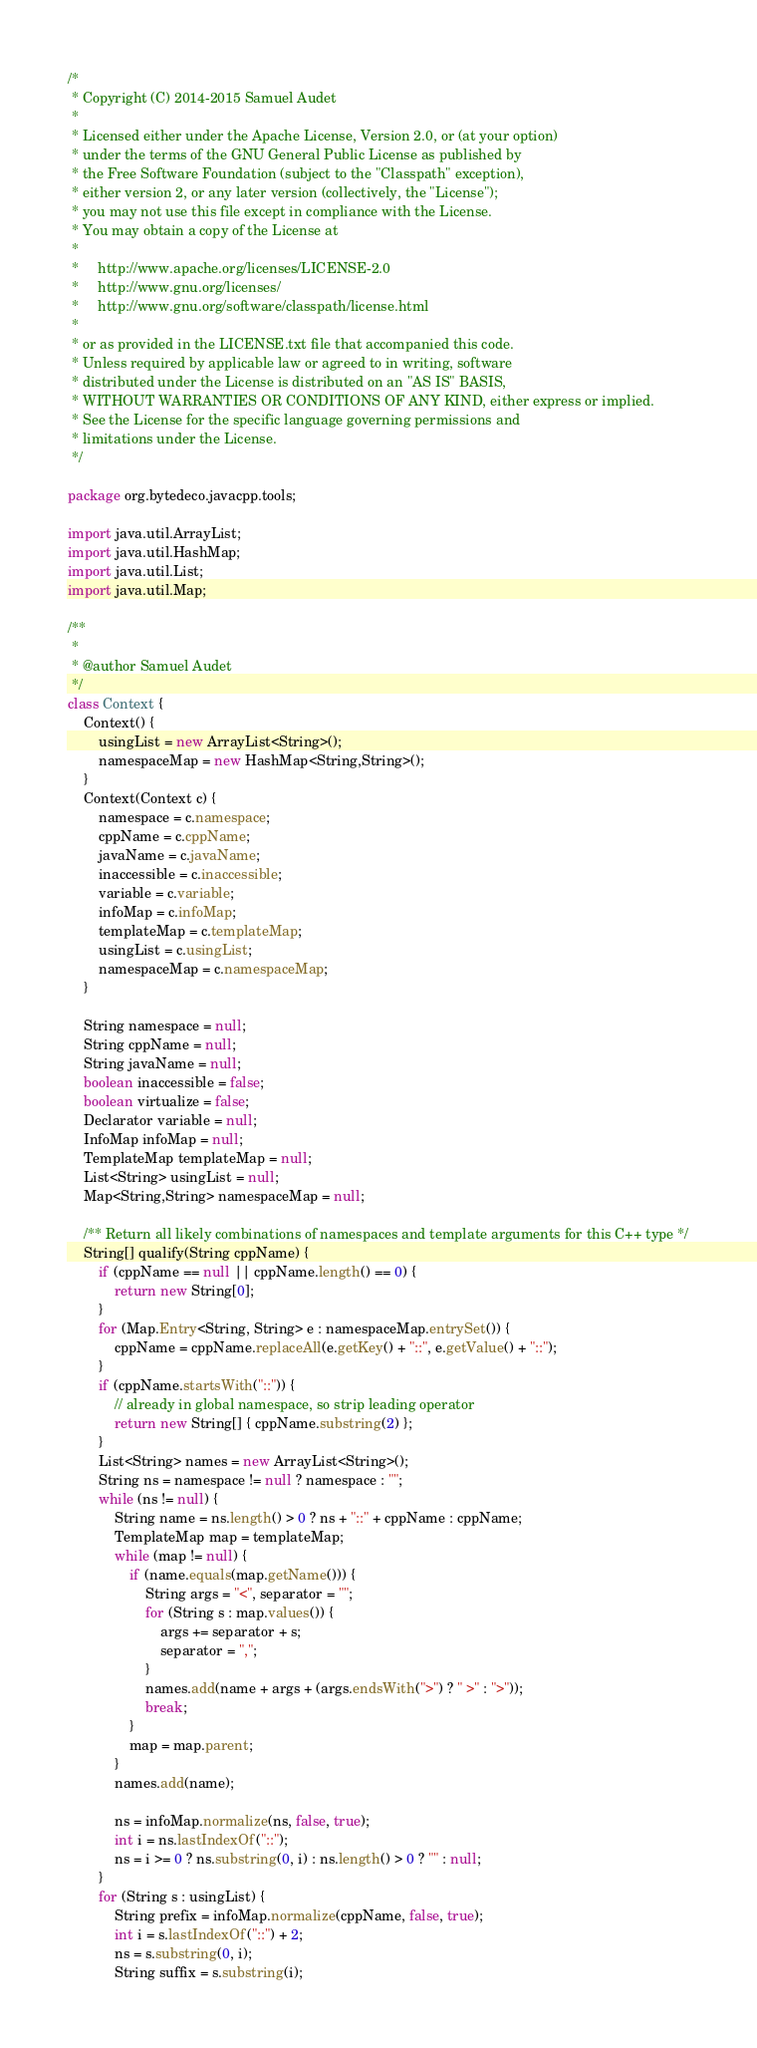<code> <loc_0><loc_0><loc_500><loc_500><_Java_>/*
 * Copyright (C) 2014-2015 Samuel Audet
 *
 * Licensed either under the Apache License, Version 2.0, or (at your option)
 * under the terms of the GNU General Public License as published by
 * the Free Software Foundation (subject to the "Classpath" exception),
 * either version 2, or any later version (collectively, the "License");
 * you may not use this file except in compliance with the License.
 * You may obtain a copy of the License at
 *
 *     http://www.apache.org/licenses/LICENSE-2.0
 *     http://www.gnu.org/licenses/
 *     http://www.gnu.org/software/classpath/license.html
 *
 * or as provided in the LICENSE.txt file that accompanied this code.
 * Unless required by applicable law or agreed to in writing, software
 * distributed under the License is distributed on an "AS IS" BASIS,
 * WITHOUT WARRANTIES OR CONDITIONS OF ANY KIND, either express or implied.
 * See the License for the specific language governing permissions and
 * limitations under the License.
 */

package org.bytedeco.javacpp.tools;

import java.util.ArrayList;
import java.util.HashMap;
import java.util.List;
import java.util.Map;

/**
 *
 * @author Samuel Audet
 */
class Context {
    Context() {
        usingList = new ArrayList<String>();
        namespaceMap = new HashMap<String,String>();
    }
    Context(Context c) {
        namespace = c.namespace;
        cppName = c.cppName;
        javaName = c.javaName;
        inaccessible = c.inaccessible;
        variable = c.variable;
        infoMap = c.infoMap;
        templateMap = c.templateMap;
        usingList = c.usingList;
        namespaceMap = c.namespaceMap;
    }

    String namespace = null;
    String cppName = null;
    String javaName = null;
    boolean inaccessible = false;
    boolean virtualize = false;
    Declarator variable = null;
    InfoMap infoMap = null;
    TemplateMap templateMap = null;
    List<String> usingList = null;
    Map<String,String> namespaceMap = null;

    /** Return all likely combinations of namespaces and template arguments for this C++ type */
    String[] qualify(String cppName) {
        if (cppName == null || cppName.length() == 0) {
            return new String[0];
        }
        for (Map.Entry<String, String> e : namespaceMap.entrySet()) {
            cppName = cppName.replaceAll(e.getKey() + "::", e.getValue() + "::");
        }
        if (cppName.startsWith("::")) {
            // already in global namespace, so strip leading operator
            return new String[] { cppName.substring(2) };
        }
        List<String> names = new ArrayList<String>();
        String ns = namespace != null ? namespace : "";
        while (ns != null) {
            String name = ns.length() > 0 ? ns + "::" + cppName : cppName;
            TemplateMap map = templateMap;
            while (map != null) {
                if (name.equals(map.getName())) {
                    String args = "<", separator = "";
                    for (String s : map.values()) {
                        args += separator + s;
                        separator = ",";
                    }
                    names.add(name + args + (args.endsWith(">") ? " >" : ">"));
                    break;
                }
                map = map.parent;
            }
            names.add(name);

            ns = infoMap.normalize(ns, false, true);
            int i = ns.lastIndexOf("::");
            ns = i >= 0 ? ns.substring(0, i) : ns.length() > 0 ? "" : null;
        }
        for (String s : usingList) {
            String prefix = infoMap.normalize(cppName, false, true);
            int i = s.lastIndexOf("::") + 2;
            ns = s.substring(0, i);
            String suffix = s.substring(i);</code> 